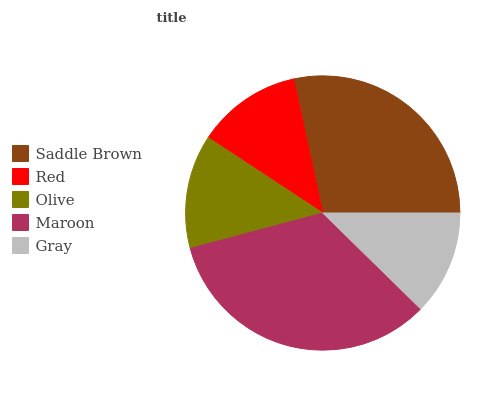Is Gray the minimum?
Answer yes or no. Yes. Is Maroon the maximum?
Answer yes or no. Yes. Is Red the minimum?
Answer yes or no. No. Is Red the maximum?
Answer yes or no. No. Is Saddle Brown greater than Red?
Answer yes or no. Yes. Is Red less than Saddle Brown?
Answer yes or no. Yes. Is Red greater than Saddle Brown?
Answer yes or no. No. Is Saddle Brown less than Red?
Answer yes or no. No. Is Olive the high median?
Answer yes or no. Yes. Is Olive the low median?
Answer yes or no. Yes. Is Maroon the high median?
Answer yes or no. No. Is Red the low median?
Answer yes or no. No. 